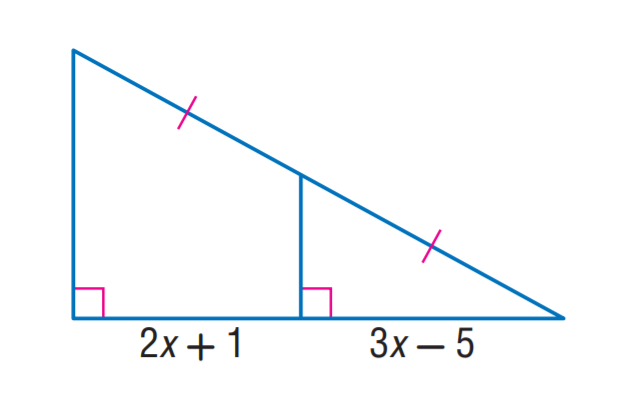Question: Find x.
Choices:
A. 2
B. 3
C. 5
D. 6
Answer with the letter. Answer: D 